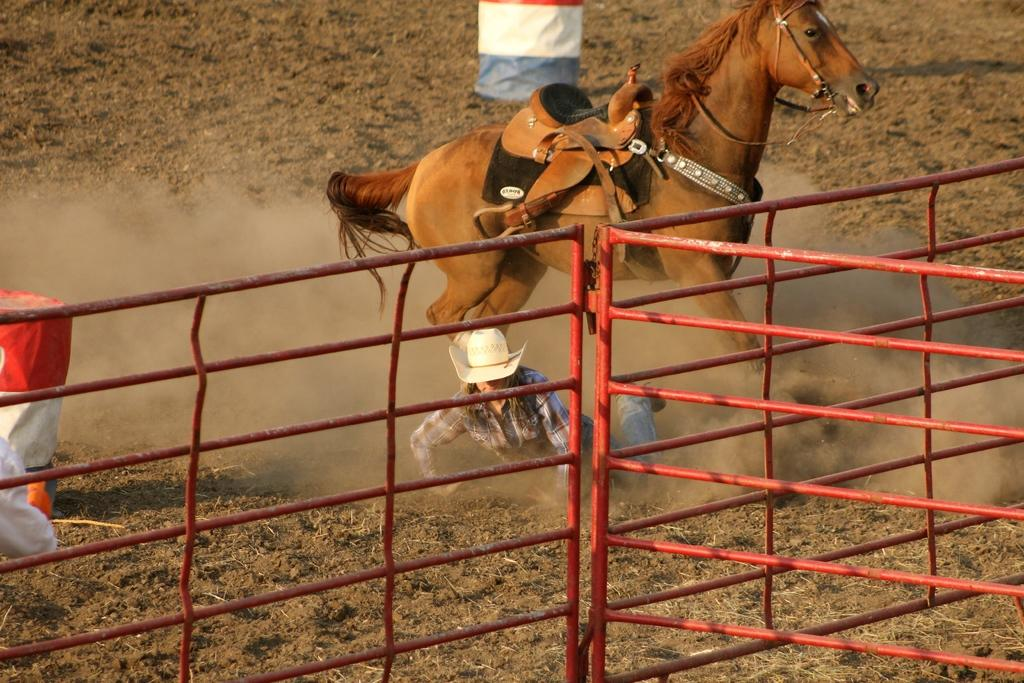What is the horse doing in the image? The horse is running with a saddle in the image. Who is near the horse, and what are they wearing? There is a person wearing a hat near the horse. What can be seen in the image that might be used for support or safety? There are railings in the image. What objects can be seen in the background of the image? There are barrels in the background of the image. What type of dirt can be seen in the garden in the image? There is no garden or dirt present in the image. How many fowl are visible in the image? There are no fowl present in the image. 